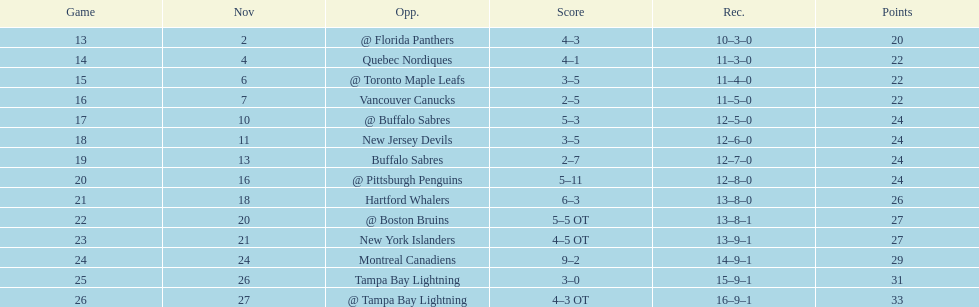Which was the only team in the atlantic division in the 1993-1994 season to acquire less points than the philadelphia flyers? Tampa Bay Lightning. 